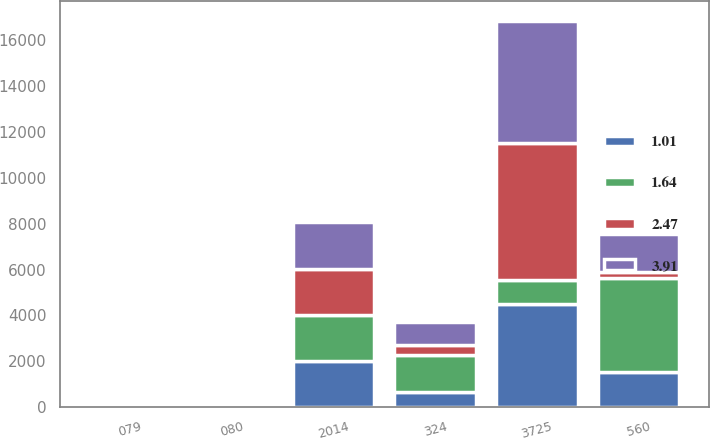Convert chart. <chart><loc_0><loc_0><loc_500><loc_500><stacked_bar_chart><ecel><fcel>2014<fcel>3725<fcel>560<fcel>324<fcel>080<fcel>079<nl><fcel>1.01<fcel>2014<fcel>4510<fcel>1554<fcel>675<fcel>1.65<fcel>1.64<nl><fcel>3.91<fcel>2014<fcel>5336<fcel>1654<fcel>1016<fcel>2.48<fcel>2.47<nl><fcel>2.47<fcel>2014<fcel>5995<fcel>291<fcel>408<fcel>1.01<fcel>1.01<nl><fcel>1.64<fcel>2014<fcel>1016<fcel>4059<fcel>1607<fcel>3.93<fcel>3.91<nl></chart> 